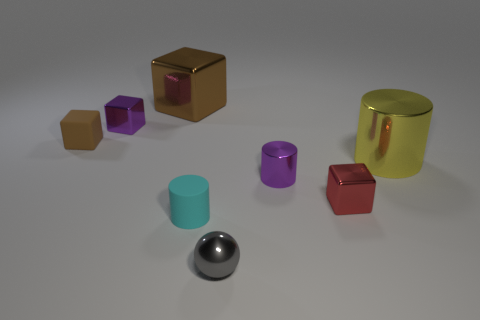Subtract all yellow balls. How many brown blocks are left? 2 Subtract all tiny red shiny cubes. How many cubes are left? 3 Subtract 1 blocks. How many blocks are left? 3 Subtract all red blocks. How many blocks are left? 3 Add 2 tiny purple balls. How many objects exist? 10 Subtract all gray cubes. Subtract all blue cylinders. How many cubes are left? 4 Subtract all cylinders. How many objects are left? 5 Subtract 0 yellow spheres. How many objects are left? 8 Subtract all tiny red cubes. Subtract all matte blocks. How many objects are left? 6 Add 2 gray metallic balls. How many gray metallic balls are left? 3 